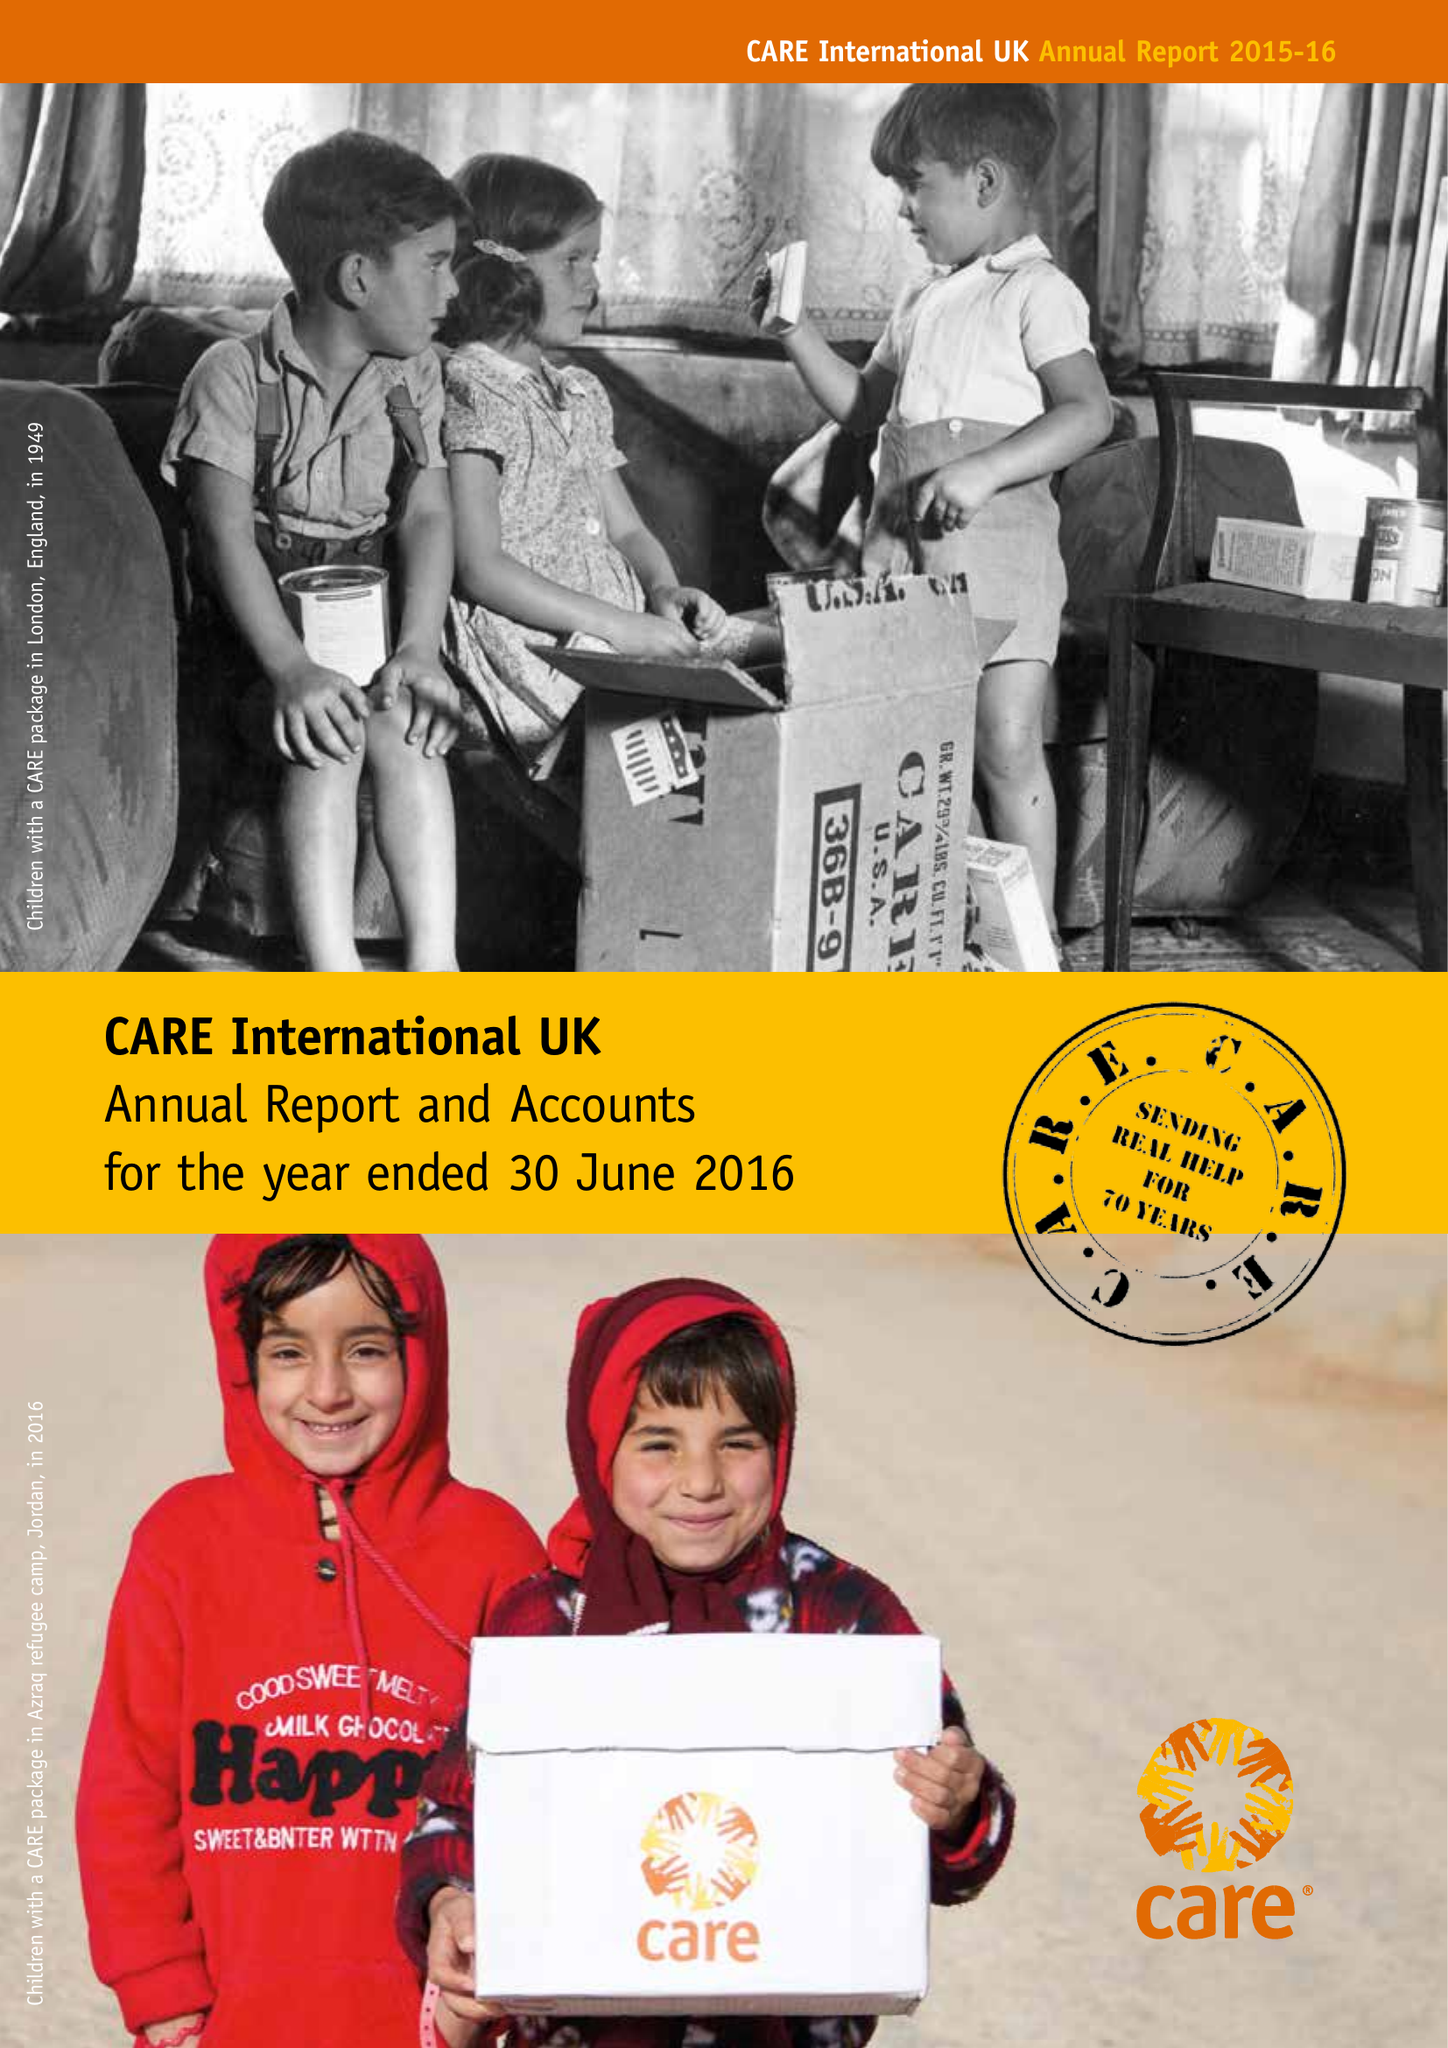What is the value for the charity_number?
Answer the question using a single word or phrase. 292506 